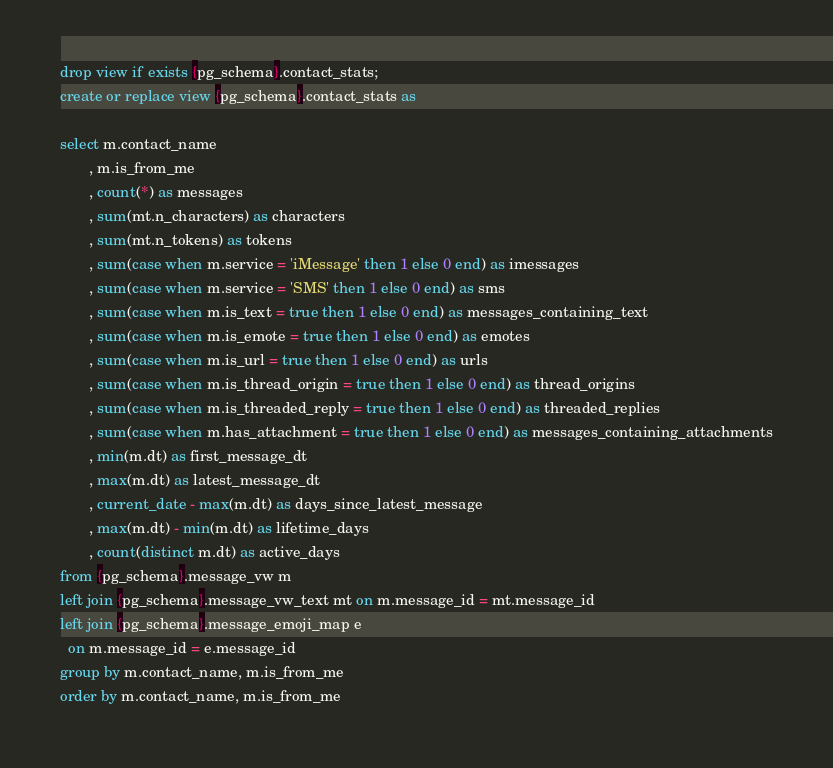Convert code to text. <code><loc_0><loc_0><loc_500><loc_500><_SQL_>drop view if exists {pg_schema}.contact_stats;
create or replace view {pg_schema}.contact_stats as

select m.contact_name
       , m.is_from_me
       , count(*) as messages
       , sum(mt.n_characters) as characters
       , sum(mt.n_tokens) as tokens
       , sum(case when m.service = 'iMessage' then 1 else 0 end) as imessages
       , sum(case when m.service = 'SMS' then 1 else 0 end) as sms
       , sum(case when m.is_text = true then 1 else 0 end) as messages_containing_text
       , sum(case when m.is_emote = true then 1 else 0 end) as emotes
       , sum(case when m.is_url = true then 1 else 0 end) as urls
       , sum(case when m.is_thread_origin = true then 1 else 0 end) as thread_origins
       , sum(case when m.is_threaded_reply = true then 1 else 0 end) as threaded_replies
       , sum(case when m.has_attachment = true then 1 else 0 end) as messages_containing_attachments
       , min(m.dt) as first_message_dt
       , max(m.dt) as latest_message_dt
       , current_date - max(m.dt) as days_since_latest_message
       , max(m.dt) - min(m.dt) as lifetime_days
       , count(distinct m.dt) as active_days
from {pg_schema}.message_vw m
left join {pg_schema}.message_vw_text mt on m.message_id = mt.message_id
left join {pg_schema}.message_emoji_map e
  on m.message_id = e.message_id
group by m.contact_name, m.is_from_me
order by m.contact_name, m.is_from_me
</code> 